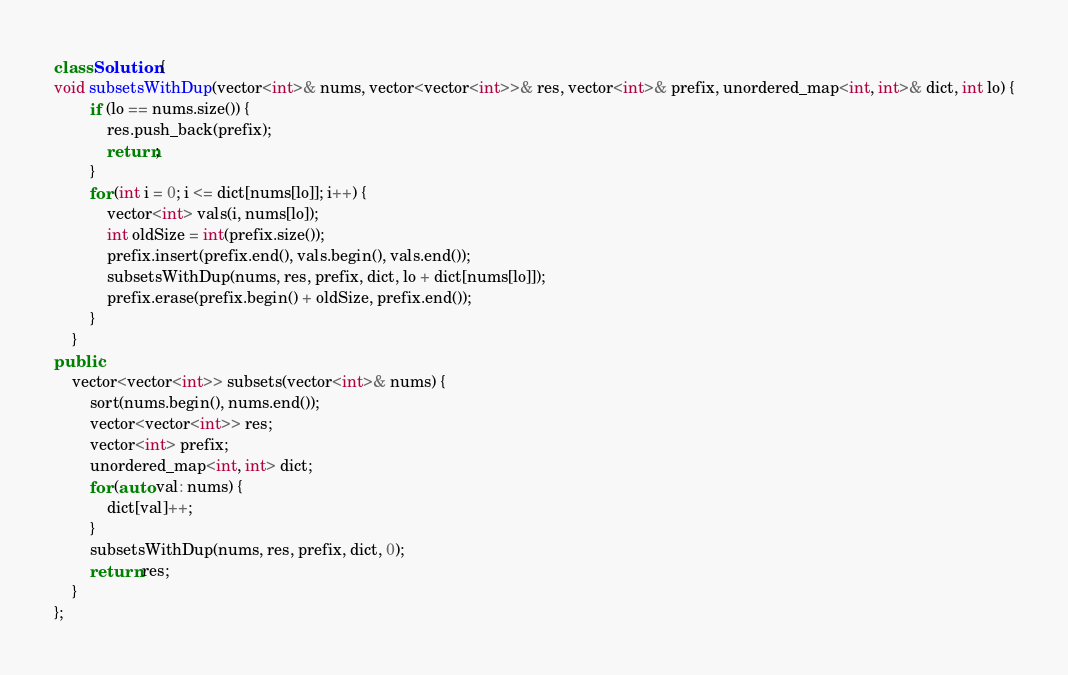Convert code to text. <code><loc_0><loc_0><loc_500><loc_500><_C++_>class Solution {
void subsetsWithDup(vector<int>& nums, vector<vector<int>>& res, vector<int>& prefix, unordered_map<int, int>& dict, int lo) {
        if (lo == nums.size()) {
            res.push_back(prefix);
            return;
        }
        for (int i = 0; i <= dict[nums[lo]]; i++) {
            vector<int> vals(i, nums[lo]);
            int oldSize = int(prefix.size());
            prefix.insert(prefix.end(), vals.begin(), vals.end());
            subsetsWithDup(nums, res, prefix, dict, lo + dict[nums[lo]]);
            prefix.erase(prefix.begin() + oldSize, prefix.end());
        }
    }
public:
    vector<vector<int>> subsets(vector<int>& nums) {
        sort(nums.begin(), nums.end());
        vector<vector<int>> res;
        vector<int> prefix;
        unordered_map<int, int> dict;
        for (auto val: nums) {
            dict[val]++;
        }
        subsetsWithDup(nums, res, prefix, dict, 0);
        return res;
    }
};
</code> 